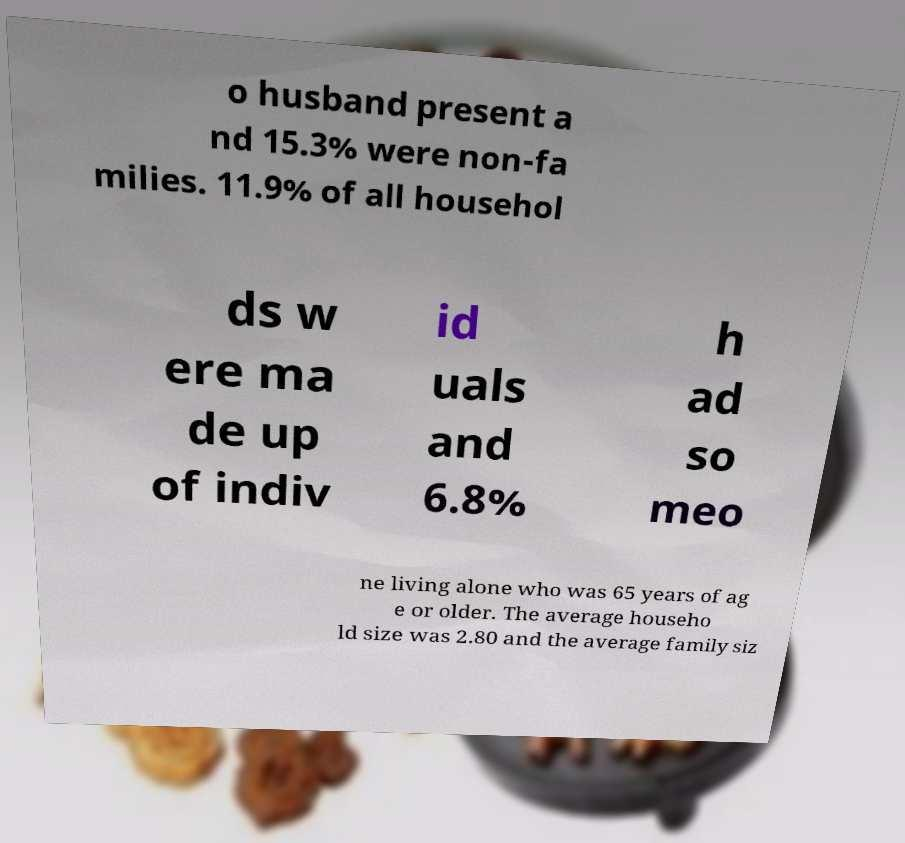For documentation purposes, I need the text within this image transcribed. Could you provide that? o husband present a nd 15.3% were non-fa milies. 11.9% of all househol ds w ere ma de up of indiv id uals and 6.8% h ad so meo ne living alone who was 65 years of ag e or older. The average househo ld size was 2.80 and the average family siz 